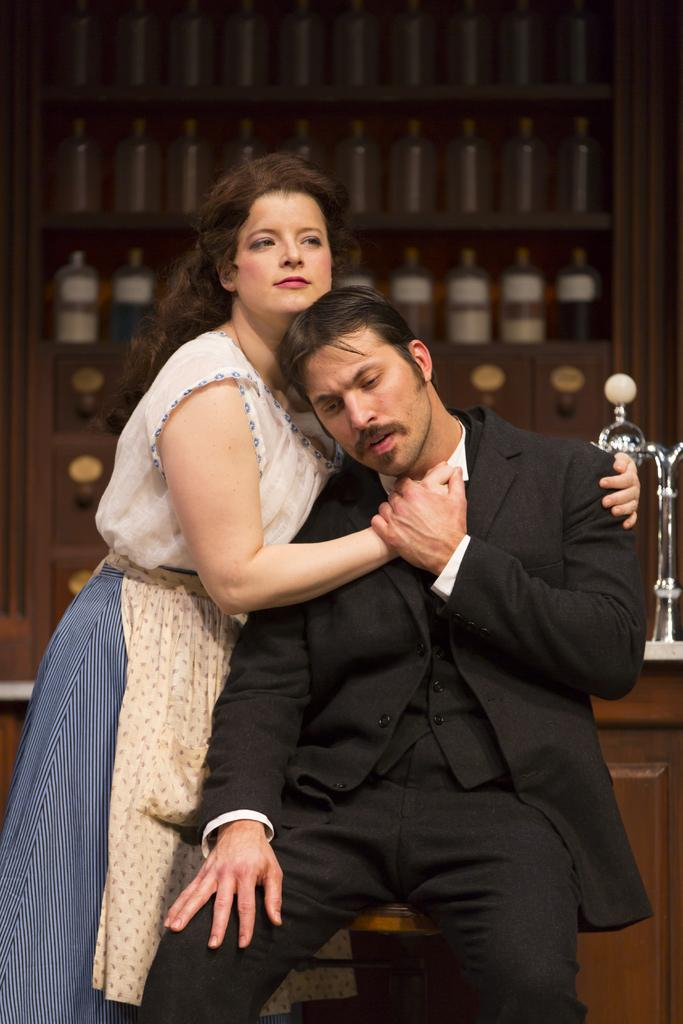How many people are in the image? There are two people in the image. Can you describe the clothing of the man in the image? The man is wearing a black color jacket. What is the woman in the image wearing? The woman is wearing a white color dress. What can be seen in the background of the image? There are bottles in the background of the image. What is the reason the man's mouth is open in the image? There is no indication in the image that the man's mouth is open, so we cannot determine the reason for it. 